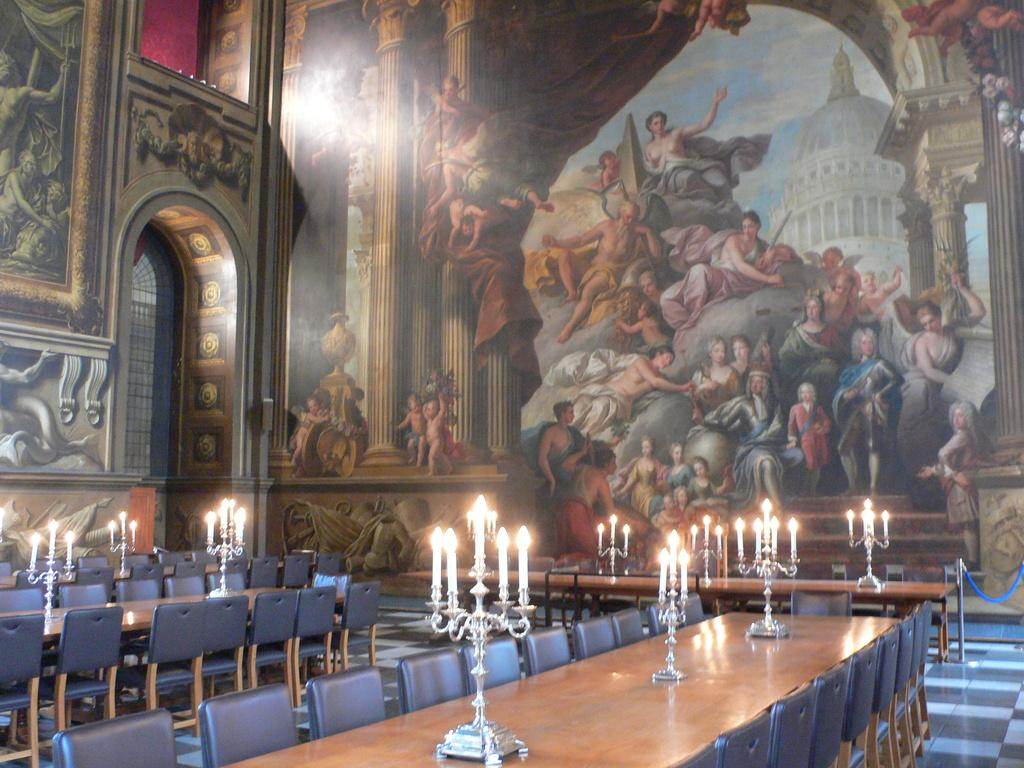What type of furniture is present in the image? There are tables and chairs in the image. What objects can be seen on the tables? There are candles with stands on the table. What can be seen in the background of the image? There is a wall and an arch in the background of the image. What decorations are on the wall? There are paintings on the wall. What type of bag is hanging from the arch in the image? There is no bag present in the image; it only features tables, chairs, candles, a wall, an arch, and paintings. 